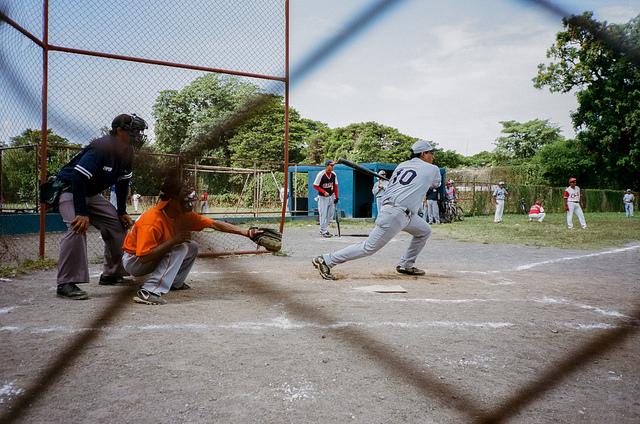What is creating the geometric pattern in the forefront of the image?
Quick response, please. Fence. What game are they playing?
Answer briefly. Baseball. The layer sliding into home plate?
Answer briefly. No. 